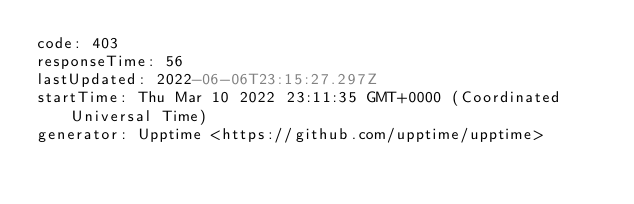<code> <loc_0><loc_0><loc_500><loc_500><_YAML_>code: 403
responseTime: 56
lastUpdated: 2022-06-06T23:15:27.297Z
startTime: Thu Mar 10 2022 23:11:35 GMT+0000 (Coordinated Universal Time)
generator: Upptime <https://github.com/upptime/upptime>
</code> 